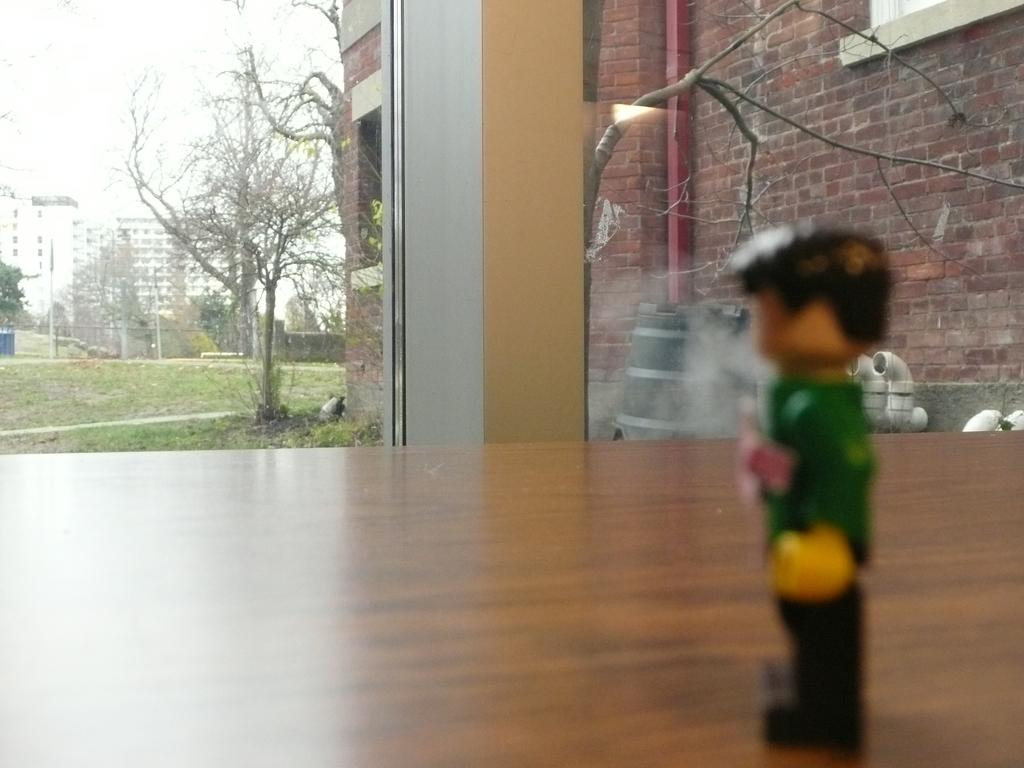What object is placed on the table on the right side of the image? There is a toy placed on the table on the right side of the image. What is located in the middle of the image? There is a building in the middle of the image. What can be seen in the background of the image? There are trees and buildings in the background of the image. What type of feather can be seen floating above the toy in the image? There is no feather present in the image; it only features a toy on the table, a building in the middle, and trees and buildings in the background. Is there a bridge visible in the image? No, there is no bridge present in the image. 